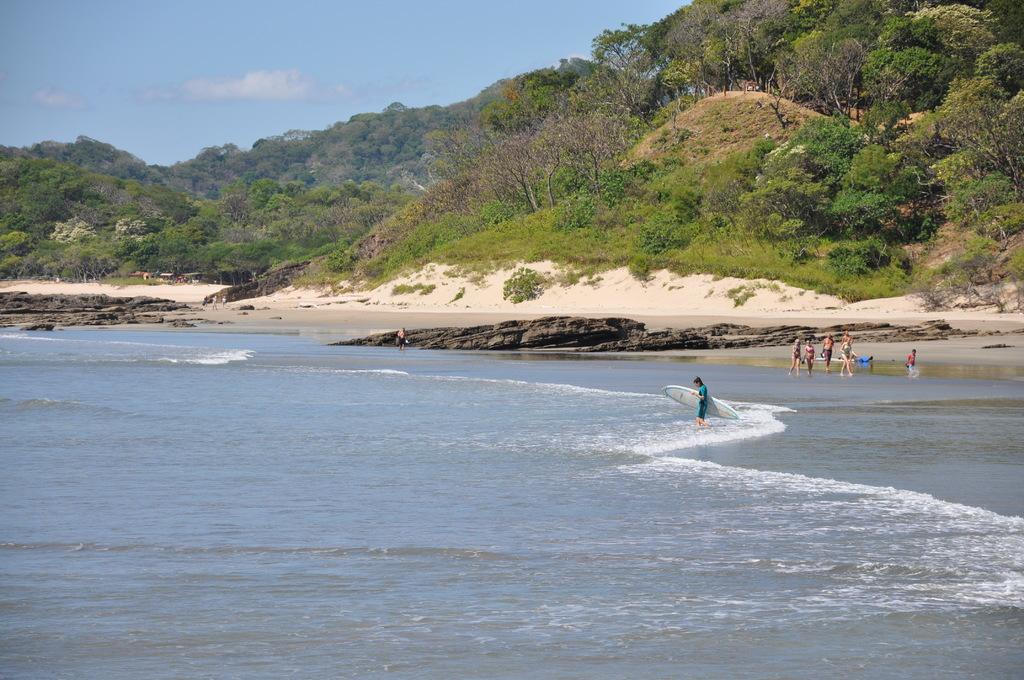What is the primary element in the image? There is water in the image. What are the people in the image doing? A person is holding a surfboard, which suggests they might be engaging in water activities. What can be seen in the background of the image? There are trees and houses in the background of the image. Can you see a squirrel running on the sidewalk in the image? There is no sidewalk or squirrel present in the image. What is the name of the downtown area visible in the image? There is no downtown area visible in the image; it features water, people, and a person holding a surfboard, with trees and houses in the background. 